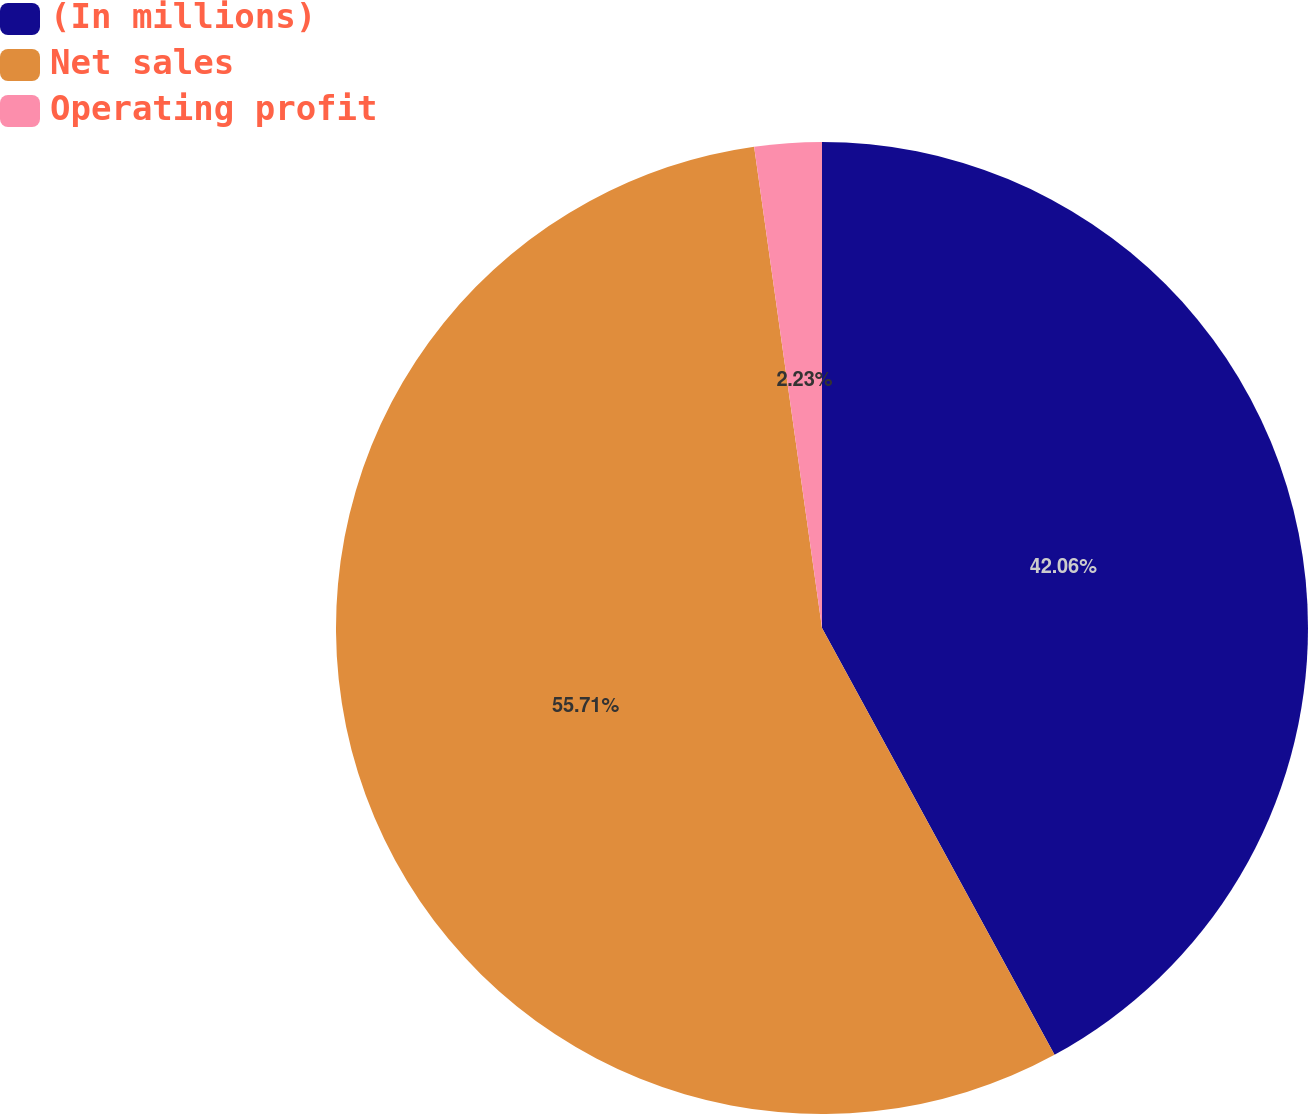Convert chart to OTSL. <chart><loc_0><loc_0><loc_500><loc_500><pie_chart><fcel>(In millions)<fcel>Net sales<fcel>Operating profit<nl><fcel>42.06%<fcel>55.71%<fcel>2.23%<nl></chart> 